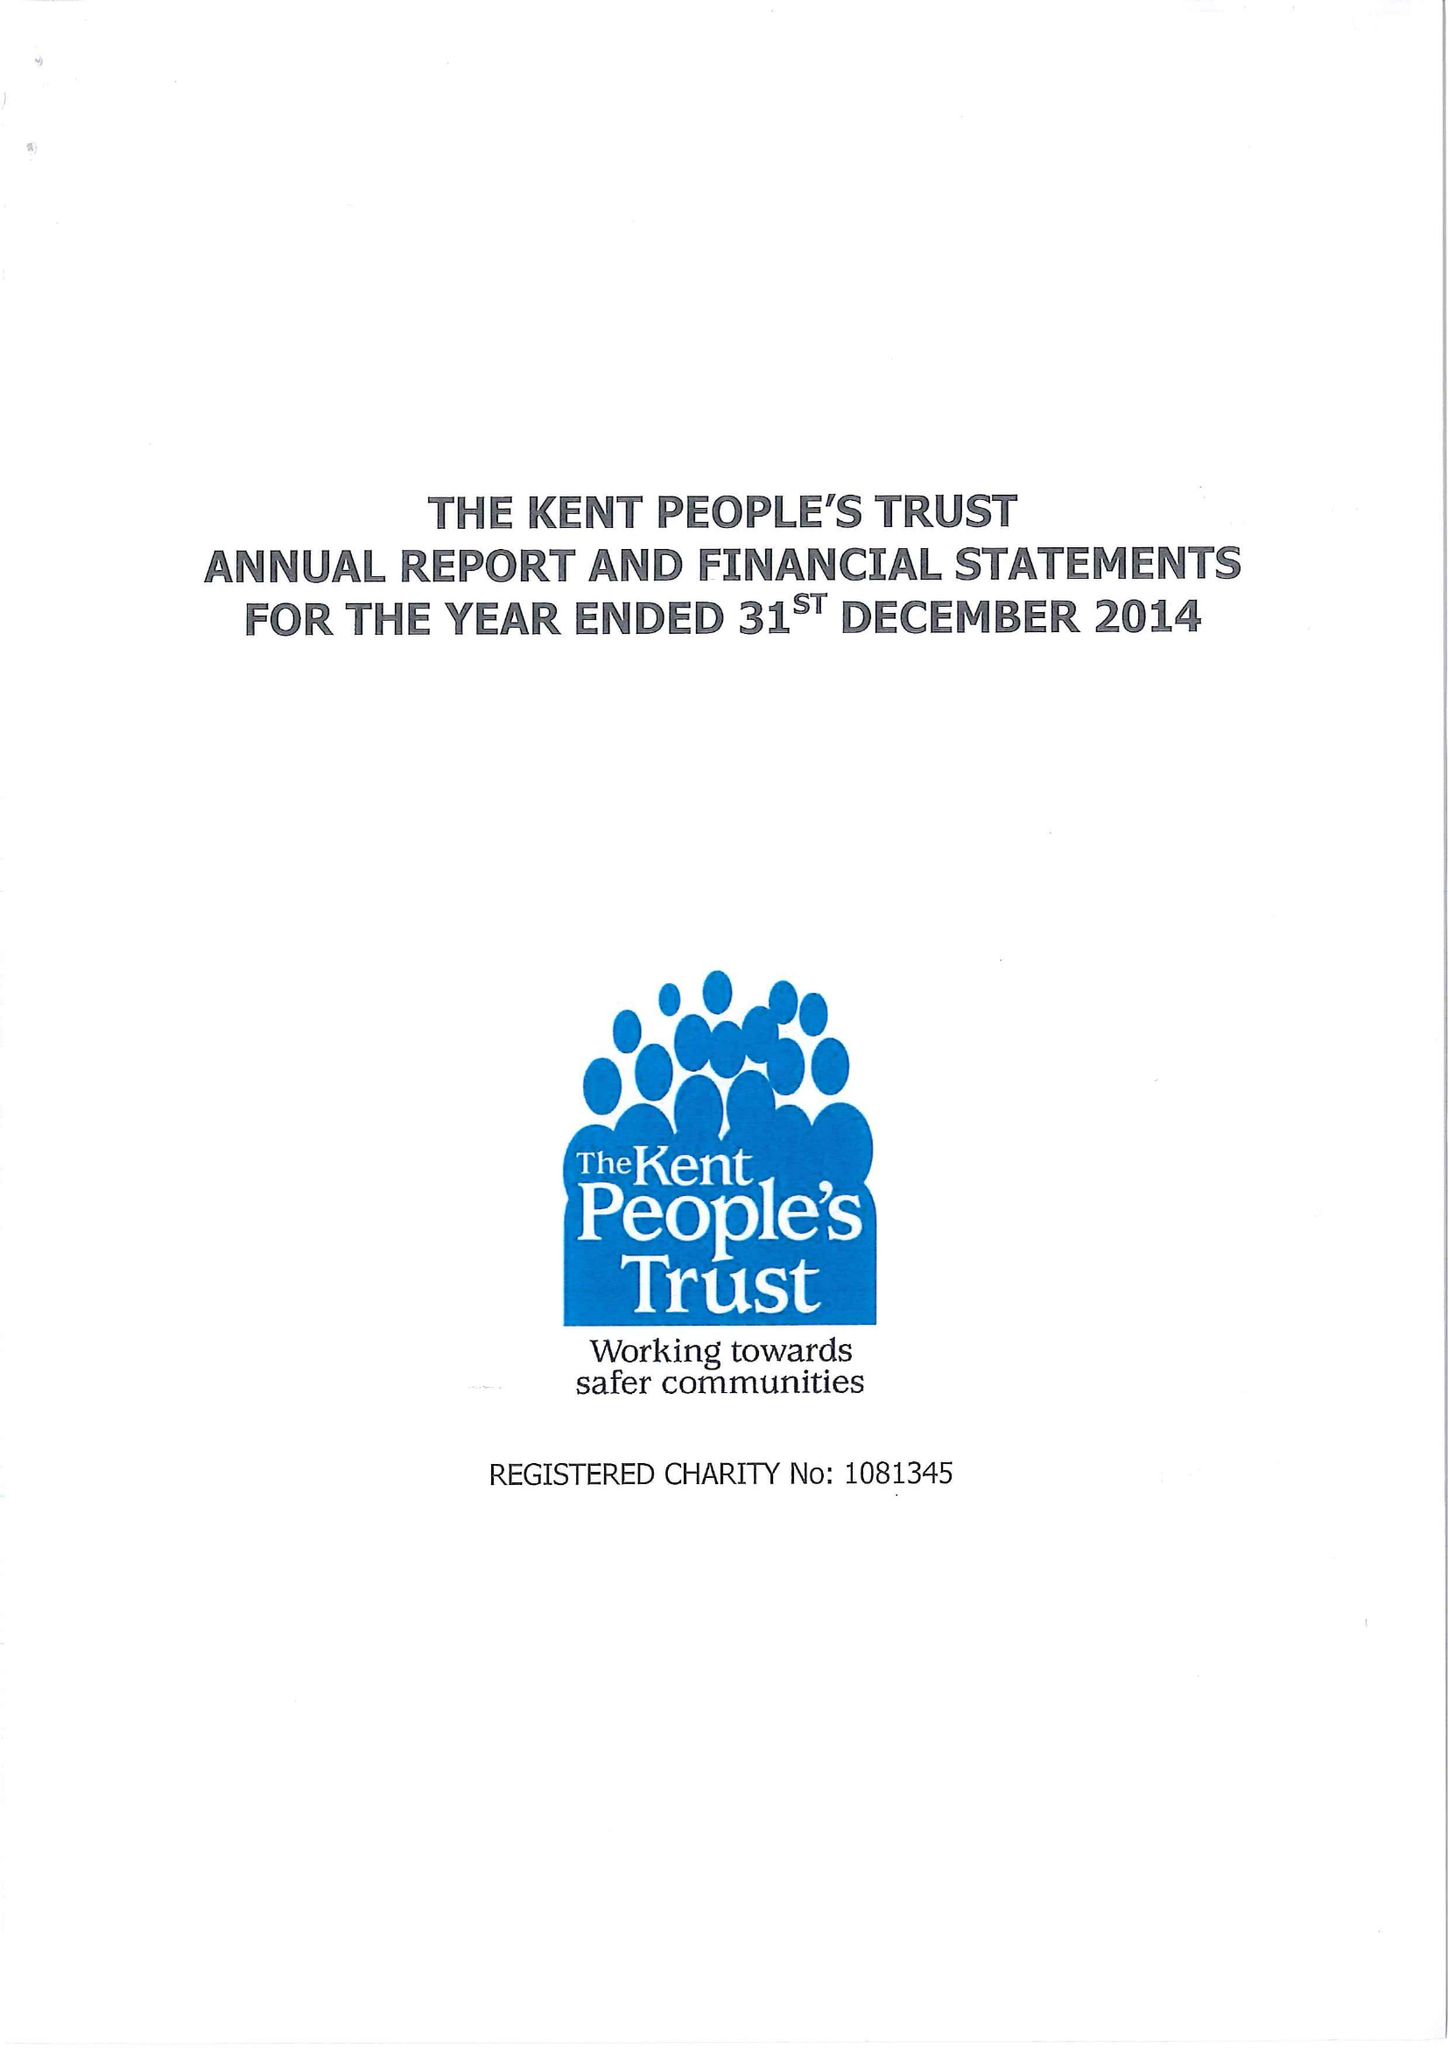What is the value for the spending_annually_in_british_pounds?
Answer the question using a single word or phrase. 105721.00 